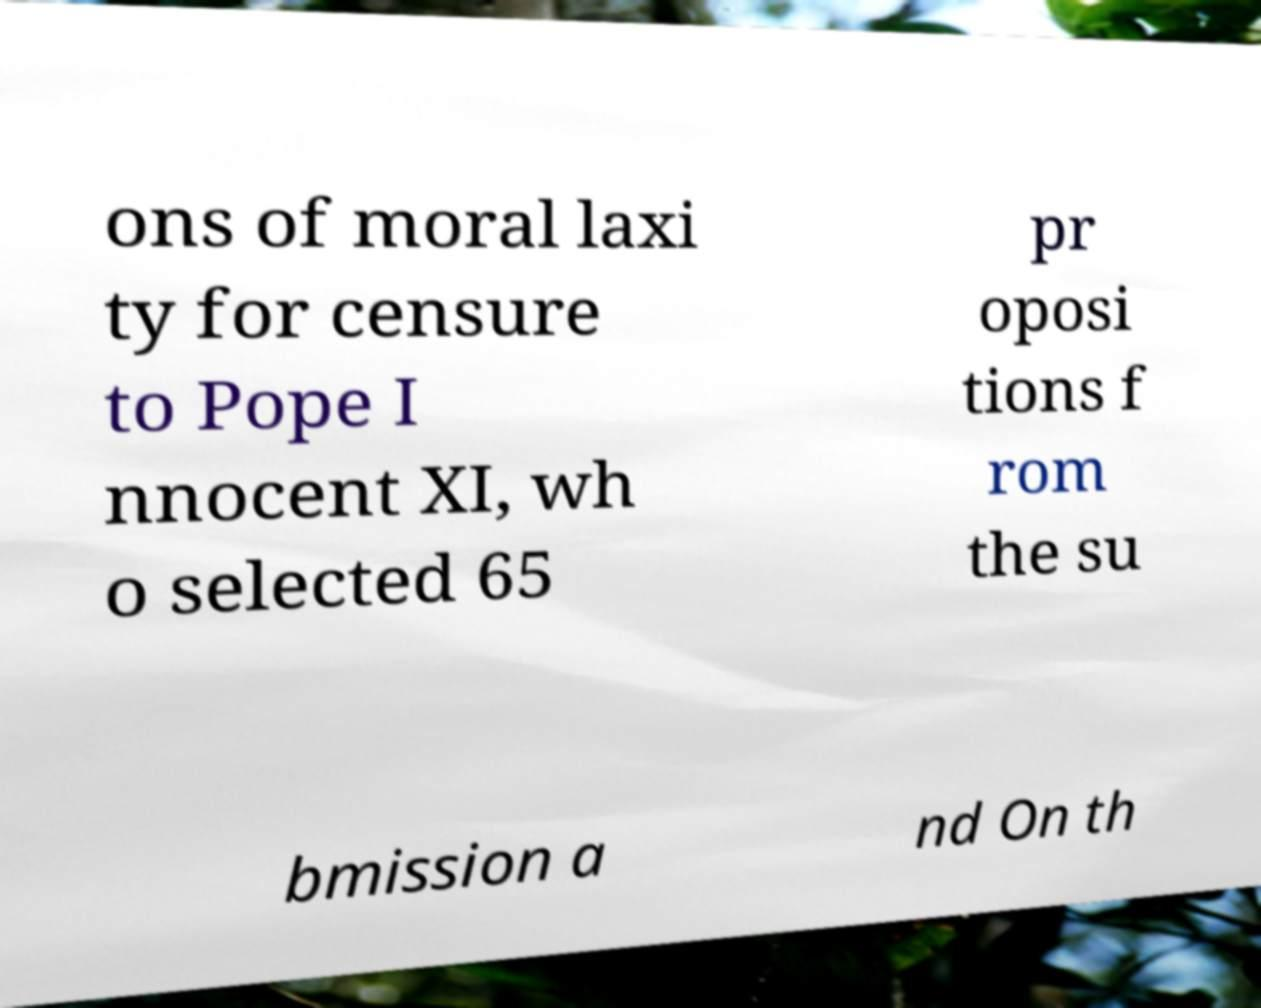Please read and relay the text visible in this image. What does it say? ons of moral laxi ty for censure to Pope I nnocent XI, wh o selected 65 pr oposi tions f rom the su bmission a nd On th 